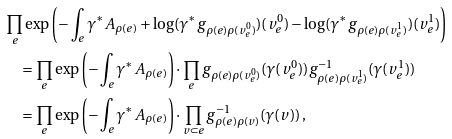Convert formula to latex. <formula><loc_0><loc_0><loc_500><loc_500>& \prod _ { e } \exp \left ( - \int _ { e } \gamma ^ { * } A _ { \rho ( e ) } + \log ( \gamma ^ { * } g _ { \rho ( e ) \rho ( v _ { e } ^ { 0 } ) } ) ( v _ { e } ^ { 0 } ) - \log ( \gamma ^ { * } g _ { \rho ( e ) \rho ( v _ { e } ^ { 1 } ) } ) ( v _ { e } ^ { 1 } ) \right ) \\ & \quad = \prod _ { e } \exp \left ( - \int _ { e } \gamma ^ { * } A _ { \rho ( e ) } \right ) \cdot \prod _ { e } g _ { \rho ( e ) \rho ( v _ { e } ^ { 0 } ) } ( \gamma ( v _ { e } ^ { 0 } ) ) g _ { \rho ( e ) \rho ( v _ { e } ^ { 1 } ) } ^ { - 1 } ( \gamma ( v _ { e } ^ { 1 } ) ) \\ & \quad = \prod _ { e } \exp \left ( - \int _ { e } \gamma ^ { * } A _ { \rho ( e ) } \right ) \cdot \prod _ { v \subset e } g ^ { - 1 } _ { \rho ( e ) \rho ( v ) } ( \gamma ( v ) ) \, ,</formula> 